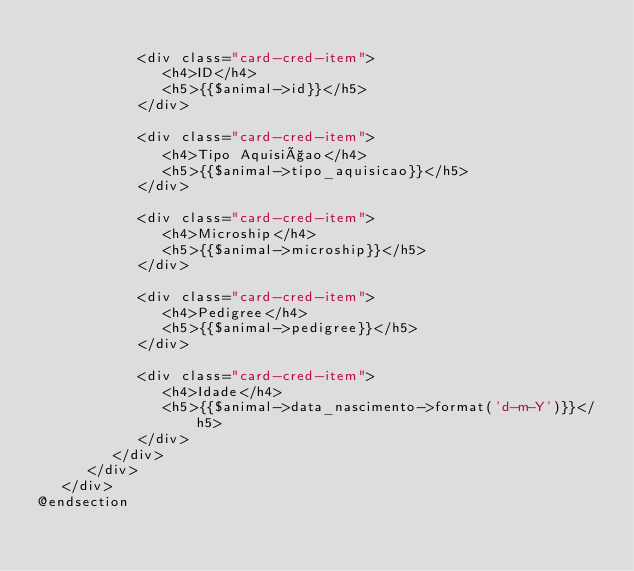<code> <loc_0><loc_0><loc_500><loc_500><_PHP_>
            <div class="card-cred-item">
               <h4>ID</h4>
               <h5>{{$animal->id}}</h5>
            </div>

            <div class="card-cred-item">
               <h4>Tipo Aquisiçao</h4>
               <h5>{{$animal->tipo_aquisicao}}</h5>
            </div>

            <div class="card-cred-item">
               <h4>Microship</h4>
               <h5>{{$animal->microship}}</h5>
            </div>

            <div class="card-cred-item">
               <h4>Pedigree</h4>
               <h5>{{$animal->pedigree}}</h5>
            </div>

            <div class="card-cred-item">
               <h4>Idade</h4>
               <h5>{{$animal->data_nascimento->format('d-m-Y')}}</h5>
            </div>
         </div>
      </div>
   </div>
@endsection
</code> 